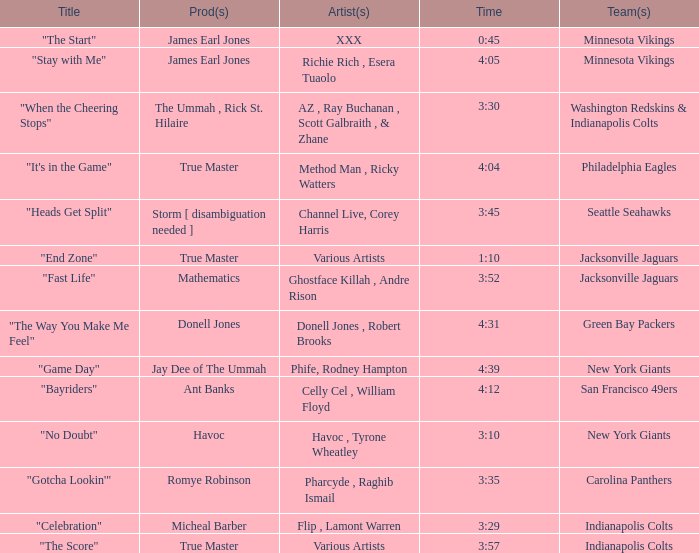Who produced "Fast Life"? Mathematics. 